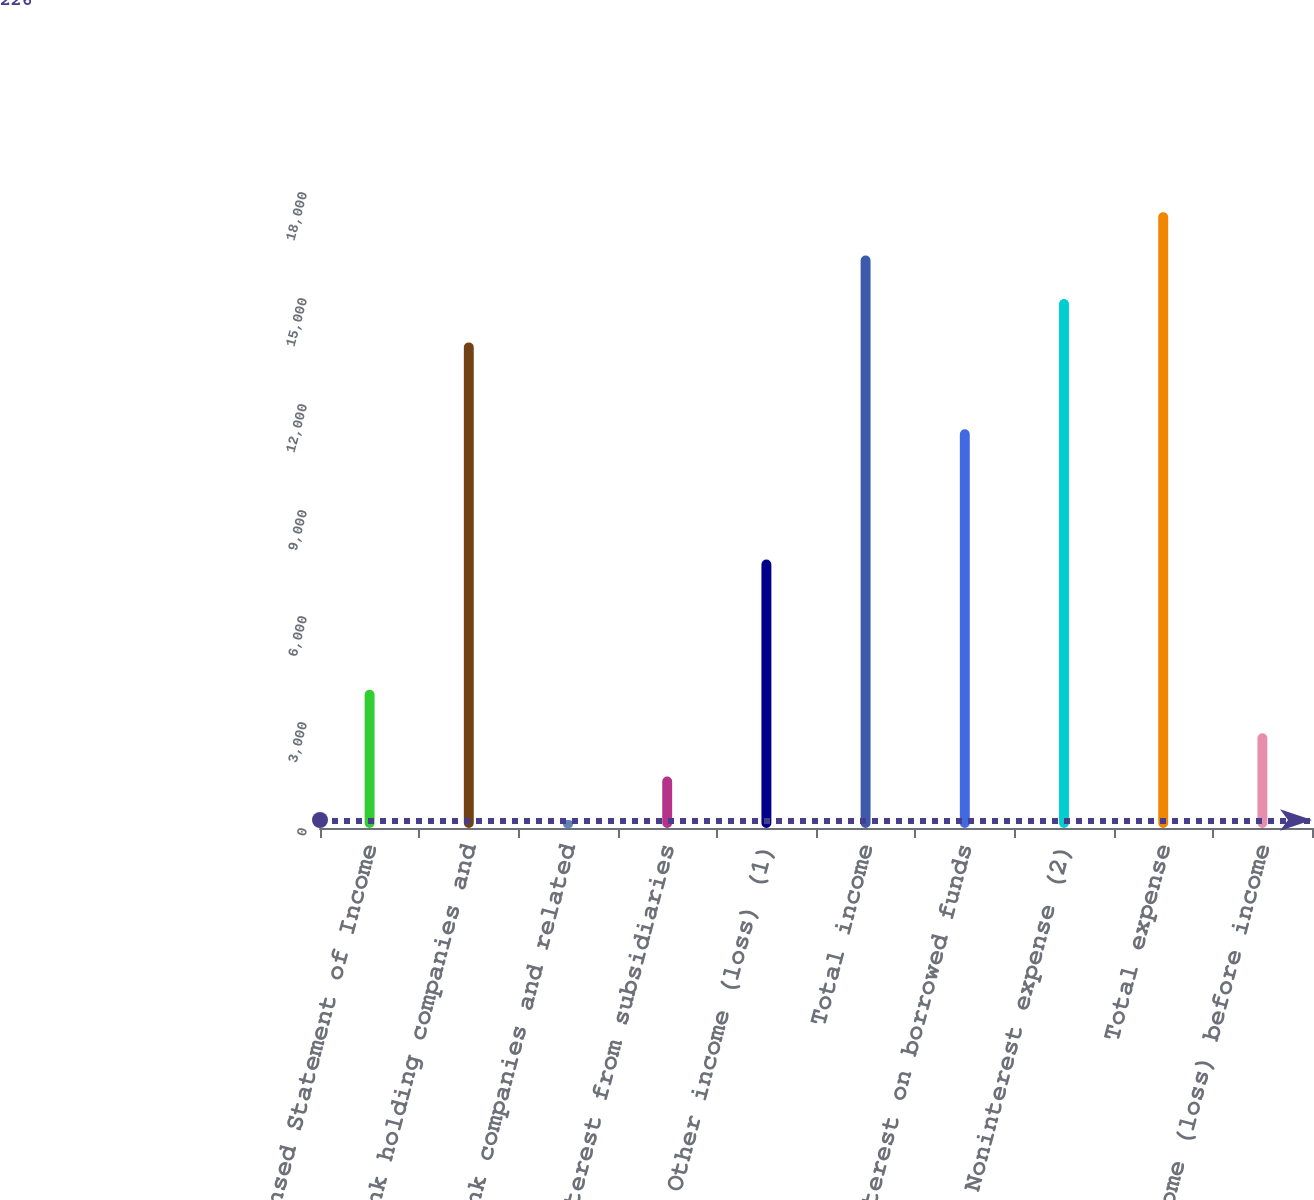Convert chart. <chart><loc_0><loc_0><loc_500><loc_500><bar_chart><fcel>Condensed Statement of Income<fcel>Bank holding companies and<fcel>Nonbank companies and related<fcel>Interest from subsidiaries<fcel>Other income (loss) (1)<fcel>Total income<fcel>Interest on borrowed funds<fcel>Noninterest expense (2)<fcel>Total expense<fcel>Income (loss) before income<nl><fcel>3912.4<fcel>13742.8<fcel>226<fcel>1454.8<fcel>7598.8<fcel>16200.4<fcel>11285.2<fcel>14971.6<fcel>17429.2<fcel>2683.6<nl></chart> 